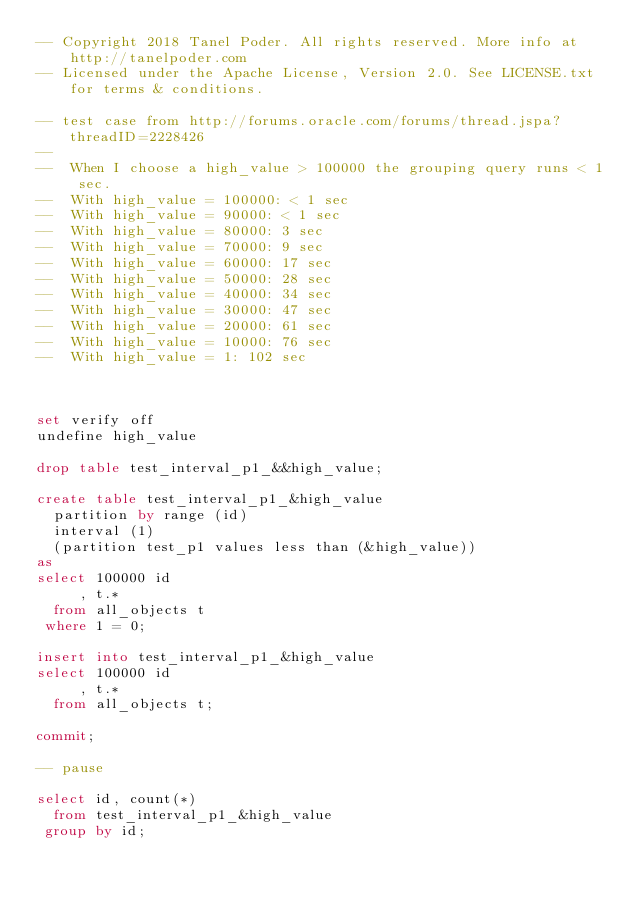Convert code to text. <code><loc_0><loc_0><loc_500><loc_500><_SQL_>-- Copyright 2018 Tanel Poder. All rights reserved. More info at http://tanelpoder.com
-- Licensed under the Apache License, Version 2.0. See LICENSE.txt for terms & conditions.

-- test case from http://forums.oracle.com/forums/thread.jspa?threadID=2228426
--
--  When I choose a high_value > 100000 the grouping query runs < 1 sec.
--  With high_value = 100000: < 1 sec
--  With high_value = 90000: < 1 sec
--  With high_value = 80000: 3 sec
--  With high_value = 70000: 9 sec
--  With high_value = 60000: 17 sec
--  With high_value = 50000: 28 sec
--  With high_value = 40000: 34 sec
--  With high_value = 30000: 47 sec
--  With high_value = 20000: 61 sec
--  With high_value = 10000: 76 sec
--  With high_value = 1: 102 sec



set verify off
undefine high_value
 
drop table test_interval_p1_&&high_value;
 
create table test_interval_p1_&high_value
  partition by range (id)
  interval (1)
  (partition test_p1 values less than (&high_value))
as
select 100000 id
     , t.*
  from all_objects t
 where 1 = 0;
 
insert into test_interval_p1_&high_value
select 100000 id
     , t.*
  from all_objects t;
 
commit;
 
-- pause
  
select id, count(*)
  from test_interval_p1_&high_value
 group by id;

</code> 